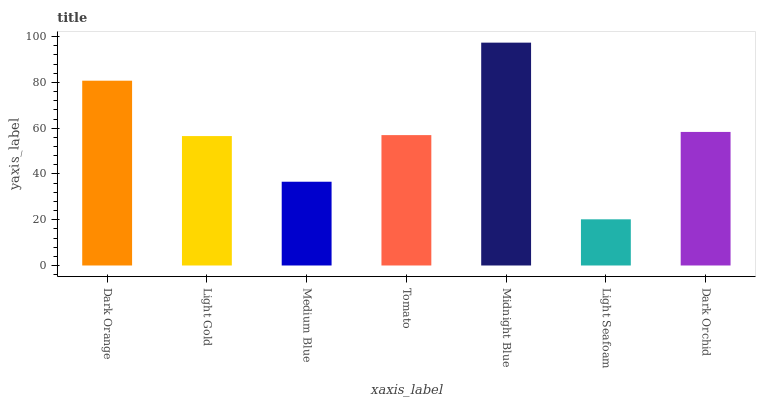Is Light Seafoam the minimum?
Answer yes or no. Yes. Is Midnight Blue the maximum?
Answer yes or no. Yes. Is Light Gold the minimum?
Answer yes or no. No. Is Light Gold the maximum?
Answer yes or no. No. Is Dark Orange greater than Light Gold?
Answer yes or no. Yes. Is Light Gold less than Dark Orange?
Answer yes or no. Yes. Is Light Gold greater than Dark Orange?
Answer yes or no. No. Is Dark Orange less than Light Gold?
Answer yes or no. No. Is Tomato the high median?
Answer yes or no. Yes. Is Tomato the low median?
Answer yes or no. Yes. Is Midnight Blue the high median?
Answer yes or no. No. Is Dark Orchid the low median?
Answer yes or no. No. 